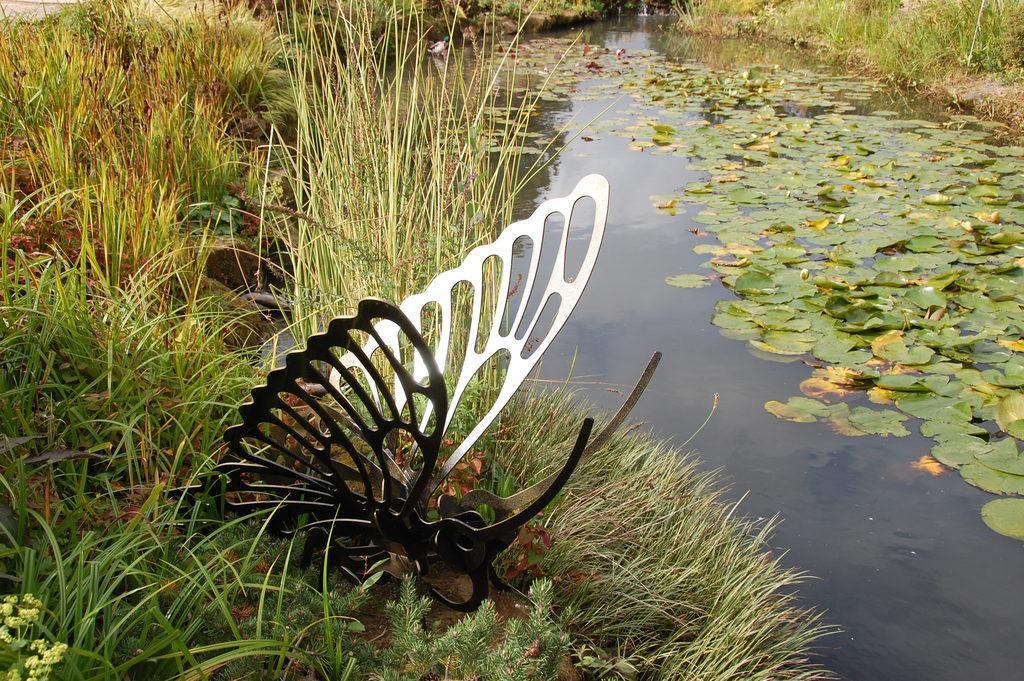Please provide a concise description of this image. At the bottom we can see a butter fly made with metal on the grass. In the background we can see leaves on the water, grass and a duck. 